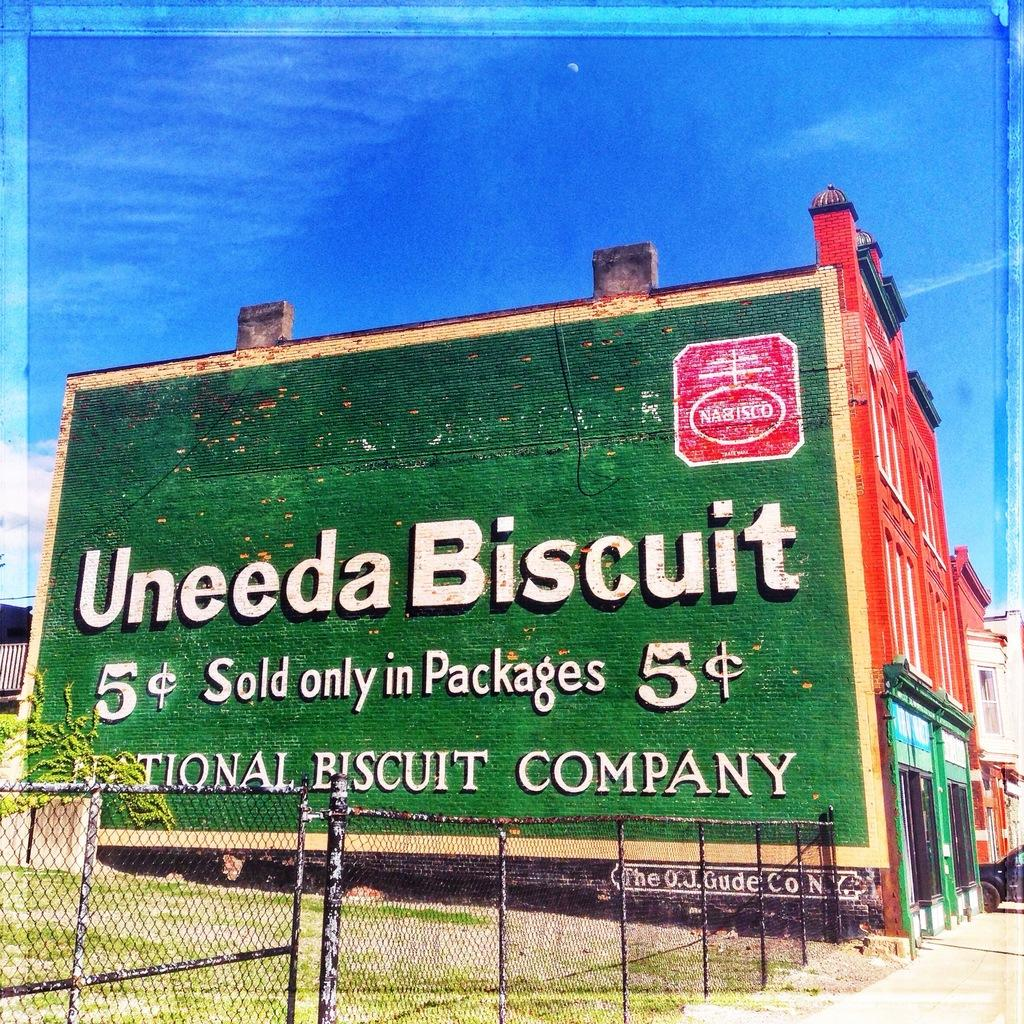What type of fencing is present in the image? There is a mesh fencing in the image. What can be seen on the grass lawn in the image? There is a plant on the grass lawn in the image. What structure is visible in the image? There is a building in the image. What is attached to the building in the image? There is a poster on the building in the image. What is visible in the background of the image? The sky is visible in the background of the image. What type of station is depicted on the poster in the image? There is no station depicted on the poster in the image; it only shows a building with a poster. What country is the edge of the grass lawn located in? The image does not provide information about the country or the location of the grass lawn's edge. 